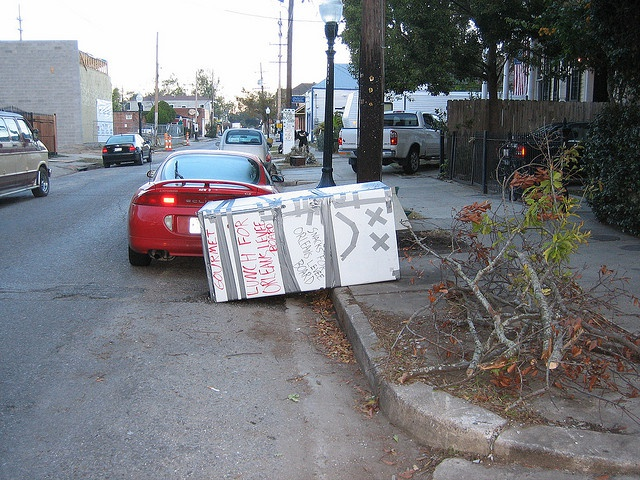Describe the objects in this image and their specific colors. I can see refrigerator in white, lightgray, darkgray, and lightblue tones, car in white, brown, lightblue, and maroon tones, truck in white, black, gray, and blue tones, car in white, darkgray, gray, and black tones, and car in white, black, gray, and lightblue tones in this image. 